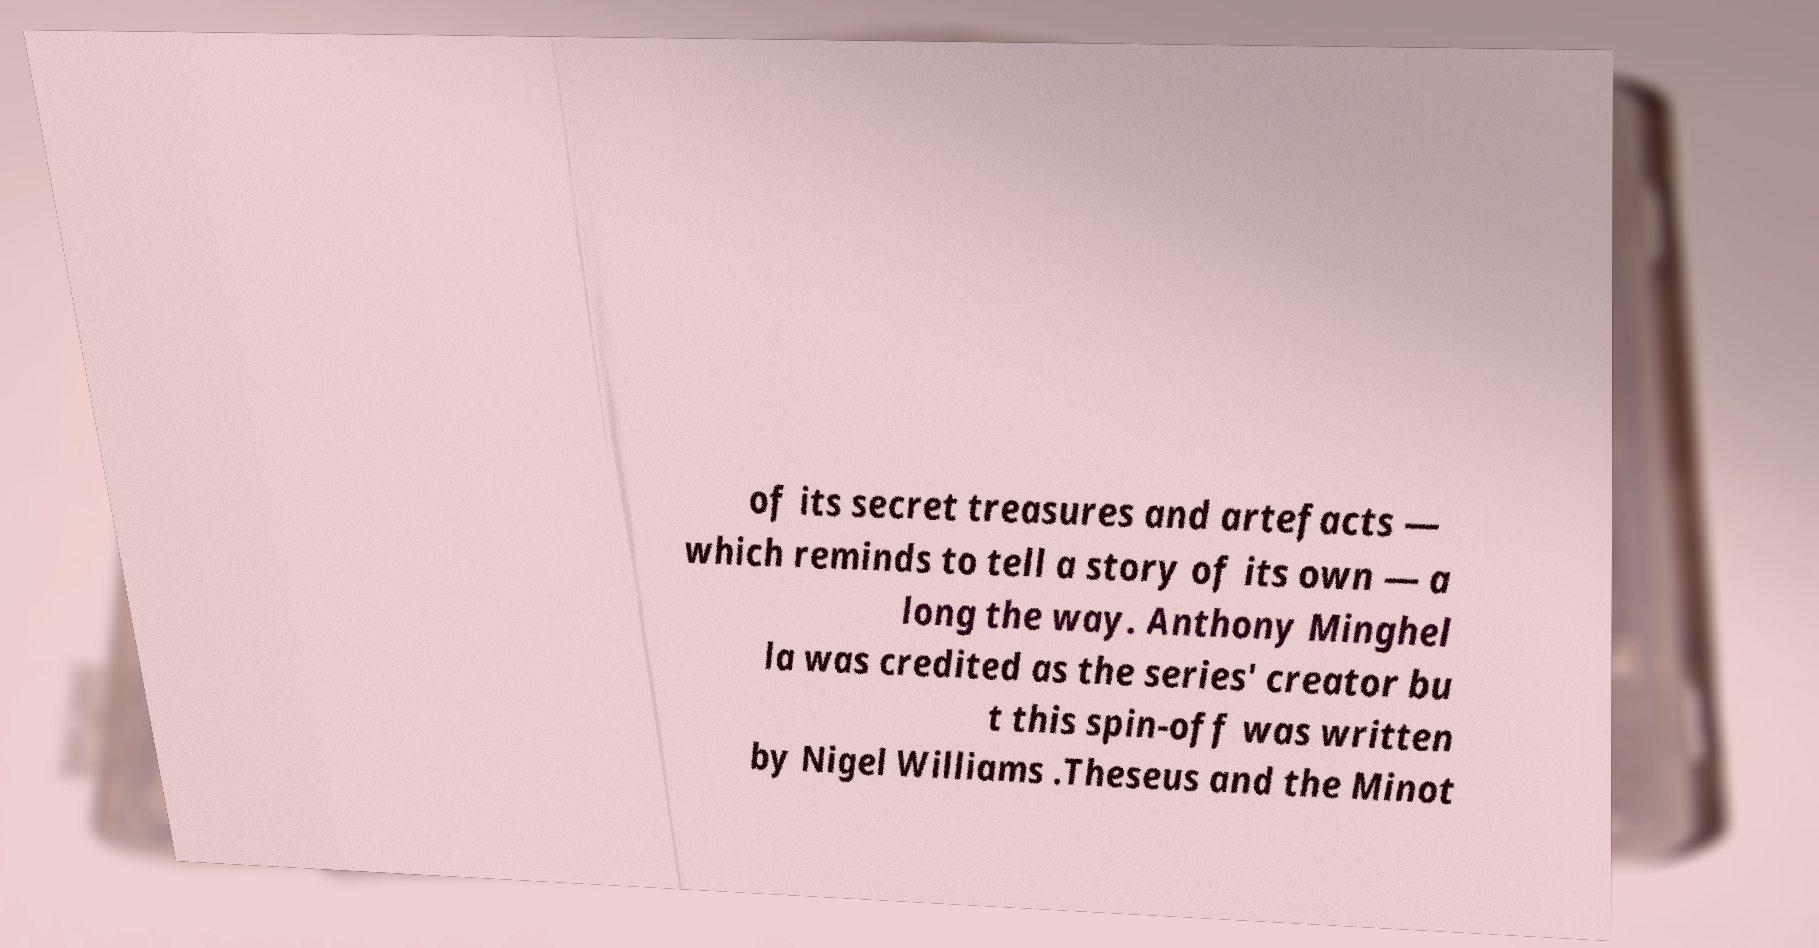Could you extract and type out the text from this image? of its secret treasures and artefacts — which reminds to tell a story of its own — a long the way. Anthony Minghel la was credited as the series' creator bu t this spin-off was written by Nigel Williams .Theseus and the Minot 